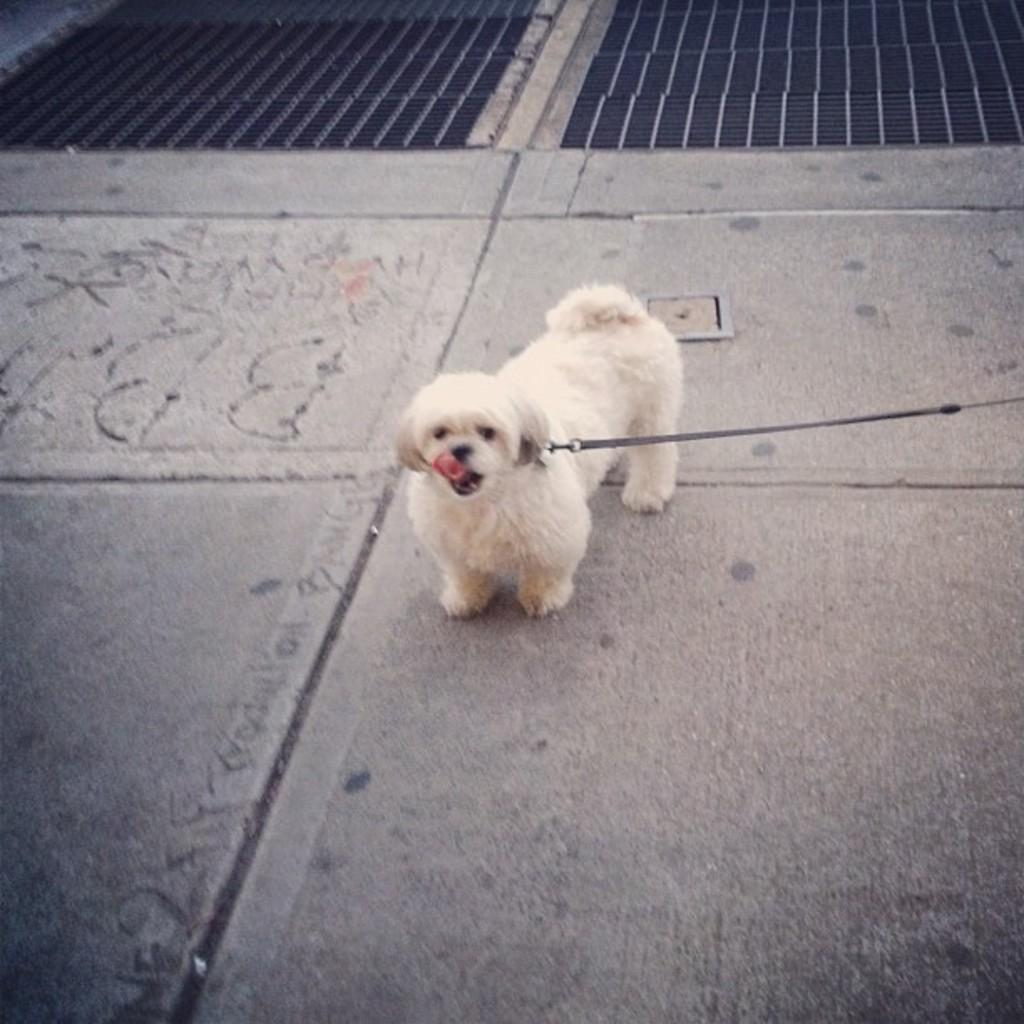What type of animal is present in the image? There is a dog in the image. Where is the dog located in the image? The dog is on the floor or an object. What type of tub is visible in the image? There is no tub present in the image. 